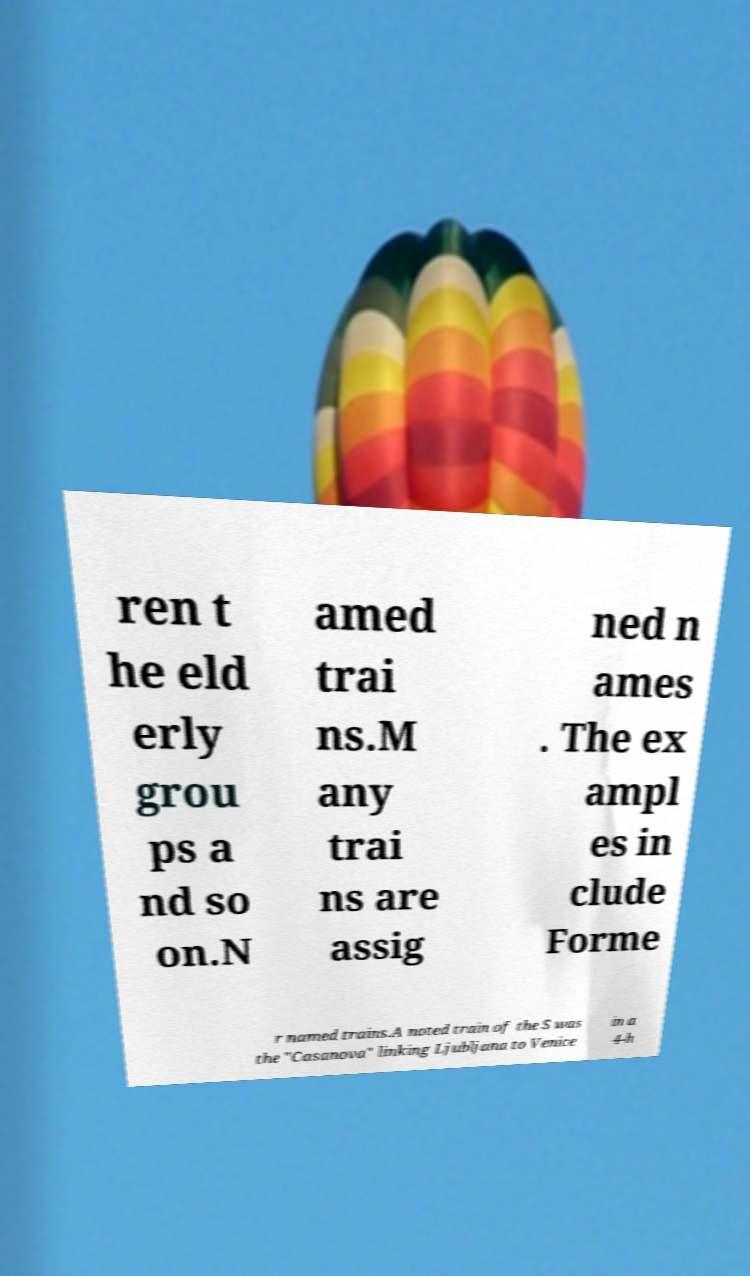I need the written content from this picture converted into text. Can you do that? ren t he eld erly grou ps a nd so on.N amed trai ns.M any trai ns are assig ned n ames . The ex ampl es in clude Forme r named trains.A noted train of the S was the "Casanova" linking Ljubljana to Venice in a 4-h 